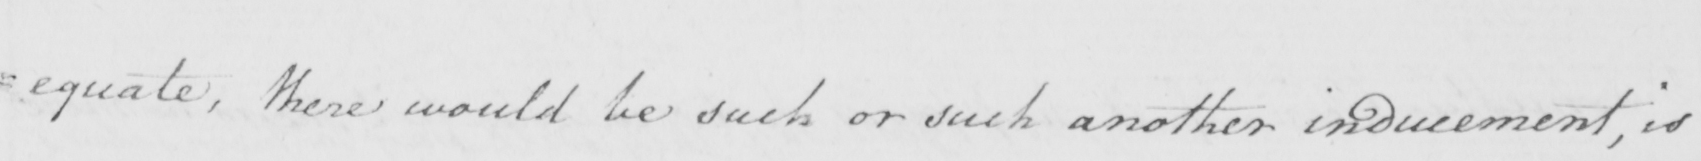What does this handwritten line say? =equate , there would be such or such another inducement , is 